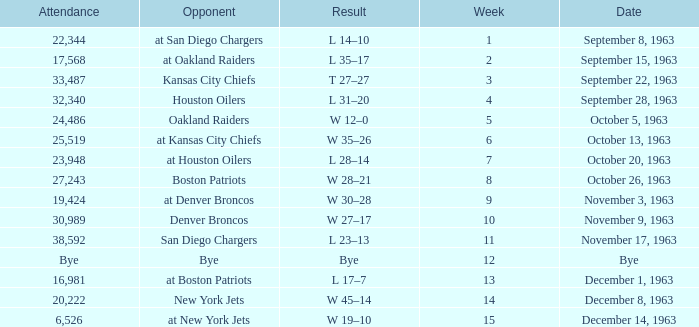Which Opponent has a Result of w 19–10? At new york jets. 